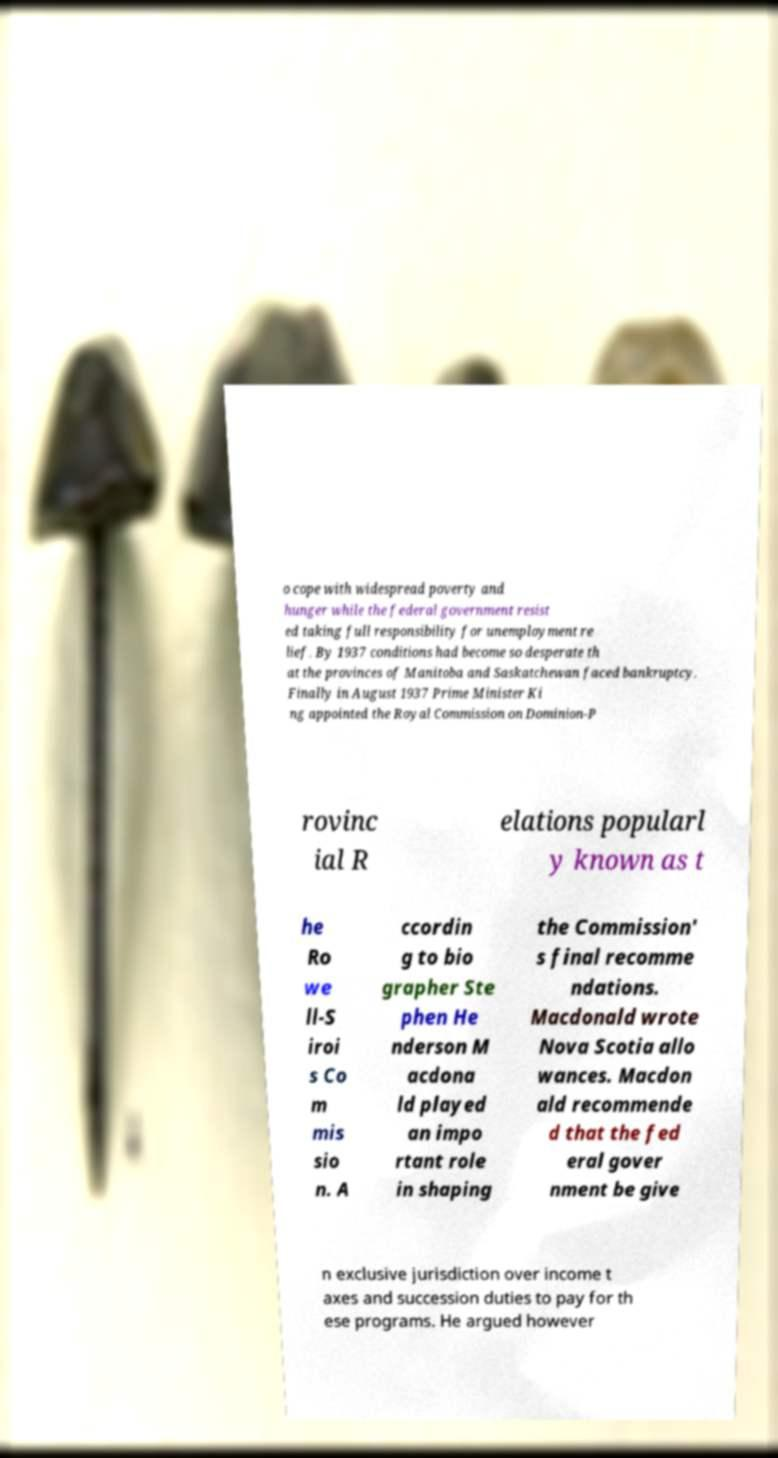Could you assist in decoding the text presented in this image and type it out clearly? o cope with widespread poverty and hunger while the federal government resist ed taking full responsibility for unemployment re lief. By 1937 conditions had become so desperate th at the provinces of Manitoba and Saskatchewan faced bankruptcy. Finally in August 1937 Prime Minister Ki ng appointed the Royal Commission on Dominion-P rovinc ial R elations popularl y known as t he Ro we ll-S iroi s Co m mis sio n. A ccordin g to bio grapher Ste phen He nderson M acdona ld played an impo rtant role in shaping the Commission' s final recomme ndations. Macdonald wrote Nova Scotia allo wances. Macdon ald recommende d that the fed eral gover nment be give n exclusive jurisdiction over income t axes and succession duties to pay for th ese programs. He argued however 